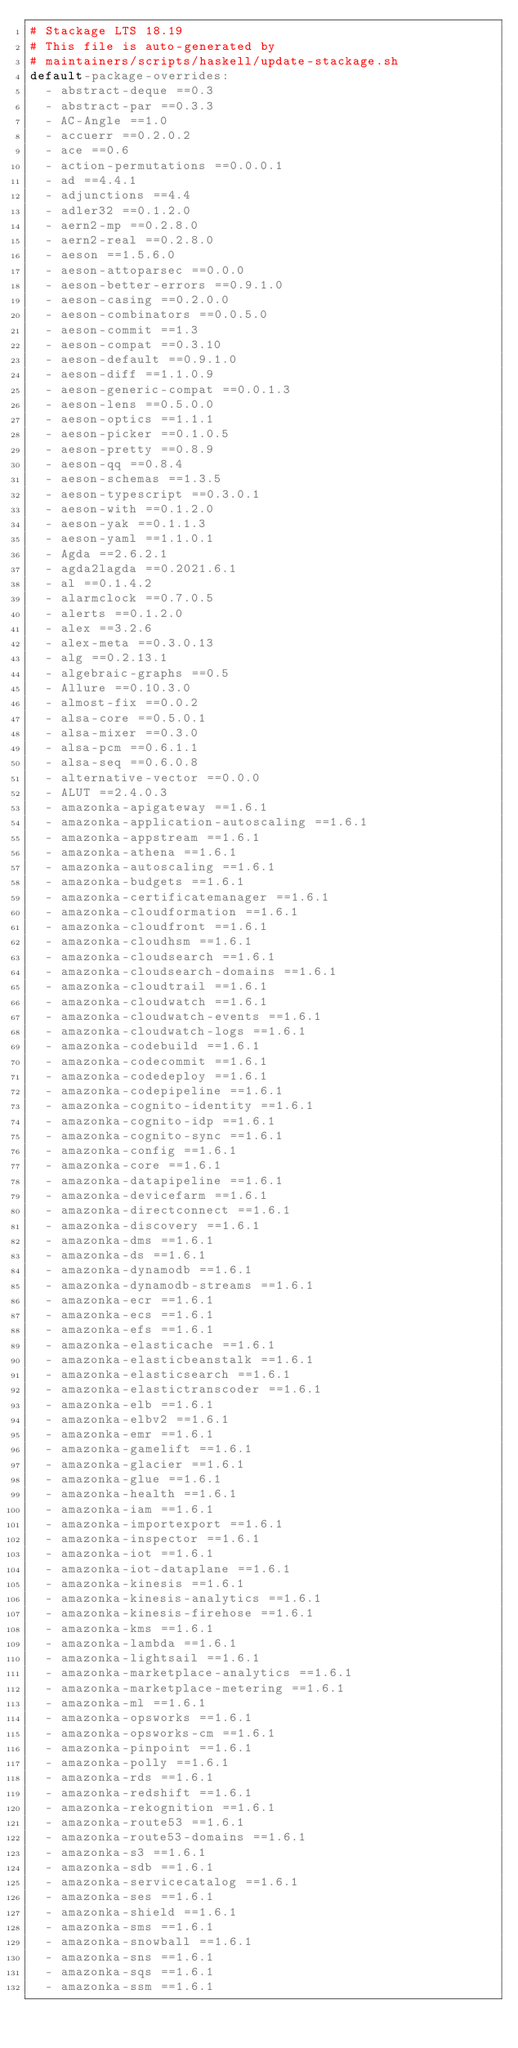<code> <loc_0><loc_0><loc_500><loc_500><_YAML_># Stackage LTS 18.19
# This file is auto-generated by
# maintainers/scripts/haskell/update-stackage.sh
default-package-overrides:
  - abstract-deque ==0.3
  - abstract-par ==0.3.3
  - AC-Angle ==1.0
  - accuerr ==0.2.0.2
  - ace ==0.6
  - action-permutations ==0.0.0.1
  - ad ==4.4.1
  - adjunctions ==4.4
  - adler32 ==0.1.2.0
  - aern2-mp ==0.2.8.0
  - aern2-real ==0.2.8.0
  - aeson ==1.5.6.0
  - aeson-attoparsec ==0.0.0
  - aeson-better-errors ==0.9.1.0
  - aeson-casing ==0.2.0.0
  - aeson-combinators ==0.0.5.0
  - aeson-commit ==1.3
  - aeson-compat ==0.3.10
  - aeson-default ==0.9.1.0
  - aeson-diff ==1.1.0.9
  - aeson-generic-compat ==0.0.1.3
  - aeson-lens ==0.5.0.0
  - aeson-optics ==1.1.1
  - aeson-picker ==0.1.0.5
  - aeson-pretty ==0.8.9
  - aeson-qq ==0.8.4
  - aeson-schemas ==1.3.5
  - aeson-typescript ==0.3.0.1
  - aeson-with ==0.1.2.0
  - aeson-yak ==0.1.1.3
  - aeson-yaml ==1.1.0.1
  - Agda ==2.6.2.1
  - agda2lagda ==0.2021.6.1
  - al ==0.1.4.2
  - alarmclock ==0.7.0.5
  - alerts ==0.1.2.0
  - alex ==3.2.6
  - alex-meta ==0.3.0.13
  - alg ==0.2.13.1
  - algebraic-graphs ==0.5
  - Allure ==0.10.3.0
  - almost-fix ==0.0.2
  - alsa-core ==0.5.0.1
  - alsa-mixer ==0.3.0
  - alsa-pcm ==0.6.1.1
  - alsa-seq ==0.6.0.8
  - alternative-vector ==0.0.0
  - ALUT ==2.4.0.3
  - amazonka-apigateway ==1.6.1
  - amazonka-application-autoscaling ==1.6.1
  - amazonka-appstream ==1.6.1
  - amazonka-athena ==1.6.1
  - amazonka-autoscaling ==1.6.1
  - amazonka-budgets ==1.6.1
  - amazonka-certificatemanager ==1.6.1
  - amazonka-cloudformation ==1.6.1
  - amazonka-cloudfront ==1.6.1
  - amazonka-cloudhsm ==1.6.1
  - amazonka-cloudsearch ==1.6.1
  - amazonka-cloudsearch-domains ==1.6.1
  - amazonka-cloudtrail ==1.6.1
  - amazonka-cloudwatch ==1.6.1
  - amazonka-cloudwatch-events ==1.6.1
  - amazonka-cloudwatch-logs ==1.6.1
  - amazonka-codebuild ==1.6.1
  - amazonka-codecommit ==1.6.1
  - amazonka-codedeploy ==1.6.1
  - amazonka-codepipeline ==1.6.1
  - amazonka-cognito-identity ==1.6.1
  - amazonka-cognito-idp ==1.6.1
  - amazonka-cognito-sync ==1.6.1
  - amazonka-config ==1.6.1
  - amazonka-core ==1.6.1
  - amazonka-datapipeline ==1.6.1
  - amazonka-devicefarm ==1.6.1
  - amazonka-directconnect ==1.6.1
  - amazonka-discovery ==1.6.1
  - amazonka-dms ==1.6.1
  - amazonka-ds ==1.6.1
  - amazonka-dynamodb ==1.6.1
  - amazonka-dynamodb-streams ==1.6.1
  - amazonka-ecr ==1.6.1
  - amazonka-ecs ==1.6.1
  - amazonka-efs ==1.6.1
  - amazonka-elasticache ==1.6.1
  - amazonka-elasticbeanstalk ==1.6.1
  - amazonka-elasticsearch ==1.6.1
  - amazonka-elastictranscoder ==1.6.1
  - amazonka-elb ==1.6.1
  - amazonka-elbv2 ==1.6.1
  - amazonka-emr ==1.6.1
  - amazonka-gamelift ==1.6.1
  - amazonka-glacier ==1.6.1
  - amazonka-glue ==1.6.1
  - amazonka-health ==1.6.1
  - amazonka-iam ==1.6.1
  - amazonka-importexport ==1.6.1
  - amazonka-inspector ==1.6.1
  - amazonka-iot ==1.6.1
  - amazonka-iot-dataplane ==1.6.1
  - amazonka-kinesis ==1.6.1
  - amazonka-kinesis-analytics ==1.6.1
  - amazonka-kinesis-firehose ==1.6.1
  - amazonka-kms ==1.6.1
  - amazonka-lambda ==1.6.1
  - amazonka-lightsail ==1.6.1
  - amazonka-marketplace-analytics ==1.6.1
  - amazonka-marketplace-metering ==1.6.1
  - amazonka-ml ==1.6.1
  - amazonka-opsworks ==1.6.1
  - amazonka-opsworks-cm ==1.6.1
  - amazonka-pinpoint ==1.6.1
  - amazonka-polly ==1.6.1
  - amazonka-rds ==1.6.1
  - amazonka-redshift ==1.6.1
  - amazonka-rekognition ==1.6.1
  - amazonka-route53 ==1.6.1
  - amazonka-route53-domains ==1.6.1
  - amazonka-s3 ==1.6.1
  - amazonka-sdb ==1.6.1
  - amazonka-servicecatalog ==1.6.1
  - amazonka-ses ==1.6.1
  - amazonka-shield ==1.6.1
  - amazonka-sms ==1.6.1
  - amazonka-snowball ==1.6.1
  - amazonka-sns ==1.6.1
  - amazonka-sqs ==1.6.1
  - amazonka-ssm ==1.6.1</code> 